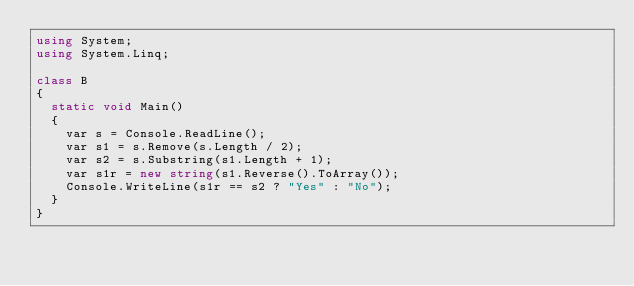<code> <loc_0><loc_0><loc_500><loc_500><_C#_>using System;
using System.Linq;

class B
{
	static void Main()
	{
		var s = Console.ReadLine();
		var s1 = s.Remove(s.Length / 2);
		var s2 = s.Substring(s1.Length + 1);
		var s1r = new string(s1.Reverse().ToArray());
		Console.WriteLine(s1r == s2 ? "Yes" : "No");
	}
}
</code> 